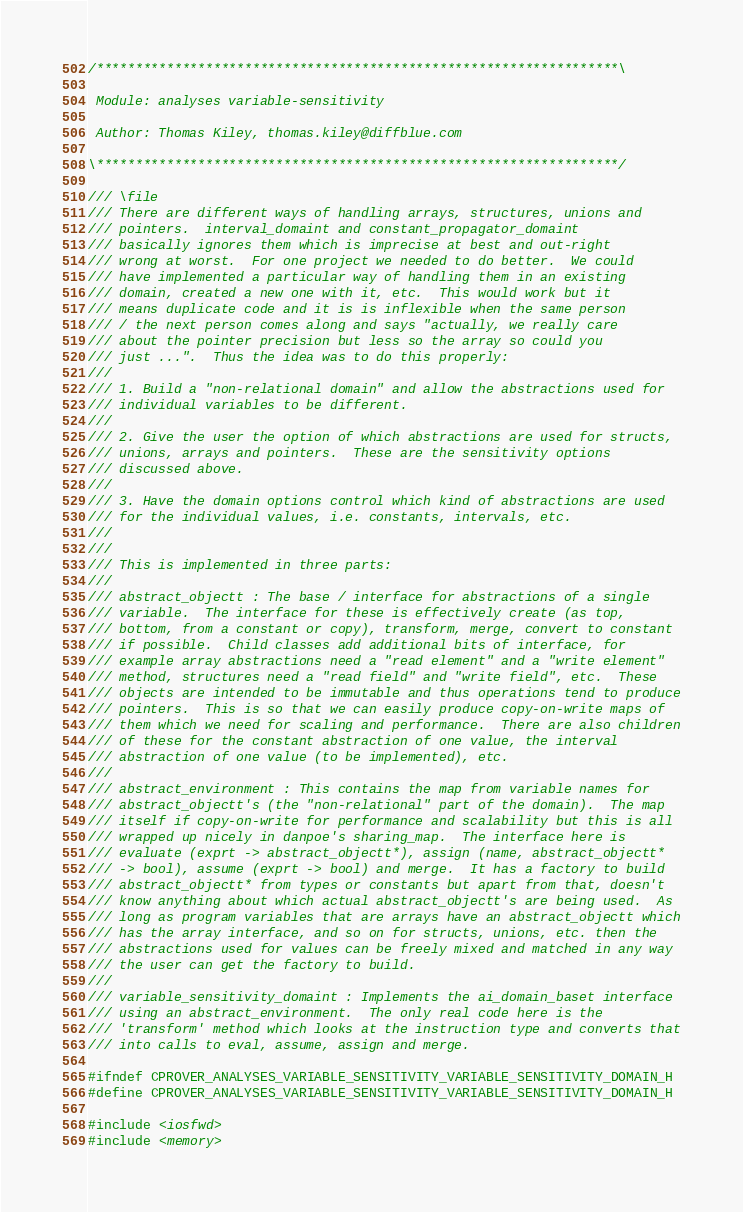Convert code to text. <code><loc_0><loc_0><loc_500><loc_500><_C_>/*******************************************************************\

 Module: analyses variable-sensitivity

 Author: Thomas Kiley, thomas.kiley@diffblue.com

\*******************************************************************/

/// \file
/// There are different ways of handling arrays, structures, unions and
/// pointers.  interval_domaint and constant_propagator_domaint
/// basically ignores them which is imprecise at best and out-right
/// wrong at worst.  For one project we needed to do better.  We could
/// have implemented a particular way of handling them in an existing
/// domain, created a new one with it, etc.  This would work but it
/// means duplicate code and it is is inflexible when the same person
/// / the next person comes along and says "actually, we really care
/// about the pointer precision but less so the array so could you
/// just ...".  Thus the idea was to do this properly:
///
/// 1. Build a "non-relational domain" and allow the abstractions used for
/// individual variables to be different.
///
/// 2. Give the user the option of which abstractions are used for structs,
/// unions, arrays and pointers.  These are the sensitivity options
/// discussed above.
///
/// 3. Have the domain options control which kind of abstractions are used
/// for the individual values, i.e. constants, intervals, etc.
///
///
/// This is implemented in three parts:
///
/// abstract_objectt : The base / interface for abstractions of a single
/// variable.  The interface for these is effectively create (as top,
/// bottom, from a constant or copy), transform, merge, convert to constant
/// if possible.  Child classes add additional bits of interface, for
/// example array abstractions need a "read element" and a "write element"
/// method, structures need a "read field" and "write field", etc.  These
/// objects are intended to be immutable and thus operations tend to produce
/// pointers.  This is so that we can easily produce copy-on-write maps of
/// them which we need for scaling and performance.  There are also children
/// of these for the constant abstraction of one value, the interval
/// abstraction of one value (to be implemented), etc.
///
/// abstract_environment : This contains the map from variable names for
/// abstract_objectt's (the "non-relational" part of the domain).  The map
/// itself if copy-on-write for performance and scalability but this is all
/// wrapped up nicely in danpoe's sharing_map.  The interface here is
/// evaluate (exprt -> abstract_objectt*), assign (name, abstract_objectt*
/// -> bool), assume (exprt -> bool) and merge.  It has a factory to build
/// abstract_objectt* from types or constants but apart from that, doesn't
/// know anything about which actual abstract_objectt's are being used.  As
/// long as program variables that are arrays have an abstract_objectt which
/// has the array interface, and so on for structs, unions, etc. then the
/// abstractions used for values can be freely mixed and matched in any way
/// the user can get the factory to build.
///
/// variable_sensitivity_domaint : Implements the ai_domain_baset interface
/// using an abstract_environment.  The only real code here is the
/// 'transform' method which looks at the instruction type and converts that
/// into calls to eval, assume, assign and merge.

#ifndef CPROVER_ANALYSES_VARIABLE_SENSITIVITY_VARIABLE_SENSITIVITY_DOMAIN_H
#define CPROVER_ANALYSES_VARIABLE_SENSITIVITY_VARIABLE_SENSITIVITY_DOMAIN_H

#include <iosfwd>
#include <memory>
</code> 